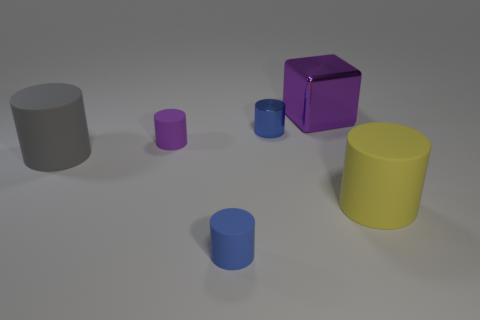How many small objects are either yellow rubber cylinders or blue metallic cubes?
Provide a short and direct response. 0. Do the small matte thing in front of the tiny purple object and the big cube have the same color?
Your response must be concise. No. Is the color of the big matte cylinder in front of the gray rubber object the same as the large cylinder that is left of the large yellow thing?
Ensure brevity in your answer.  No. Is there a big purple thing made of the same material as the yellow object?
Your response must be concise. No. What number of blue objects are either big rubber blocks or matte cylinders?
Offer a terse response. 1. Is the number of small blue matte cylinders on the right side of the purple block greater than the number of purple cylinders?
Provide a short and direct response. No. Do the yellow rubber object and the purple rubber cylinder have the same size?
Offer a very short reply. No. What is the color of the other thing that is the same material as the big purple object?
Provide a short and direct response. Blue. What is the shape of the tiny matte thing that is the same color as the small metal thing?
Your answer should be compact. Cylinder. Are there the same number of small metal things that are to the right of the small metallic thing and big rubber things that are on the right side of the big gray thing?
Make the answer very short. No. 